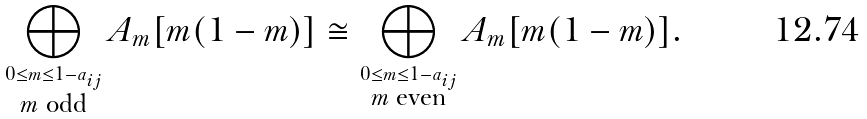<formula> <loc_0><loc_0><loc_500><loc_500>\bigoplus _ { \stackrel { 0 \leq m \leq 1 - a _ { i j } } { \text {$m$ odd} } } A _ { m } [ m ( 1 - m ) ] \cong \bigoplus _ { \stackrel { 0 \leq m \leq 1 - a _ { i j } } { \text {$m$ even} } } A _ { m } [ m ( 1 - m ) ] .</formula> 